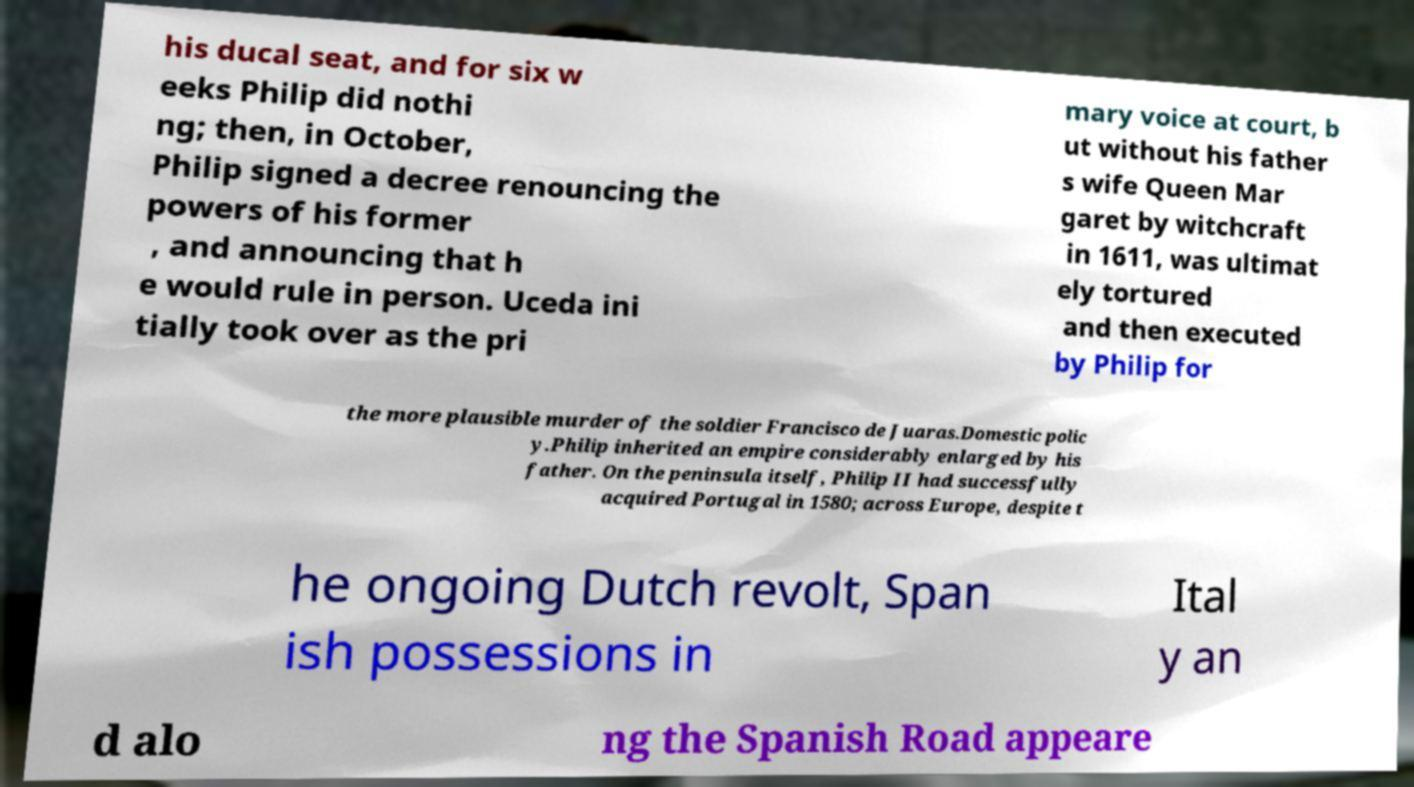I need the written content from this picture converted into text. Can you do that? his ducal seat, and for six w eeks Philip did nothi ng; then, in October, Philip signed a decree renouncing the powers of his former , and announcing that h e would rule in person. Uceda ini tially took over as the pri mary voice at court, b ut without his father s wife Queen Mar garet by witchcraft in 1611, was ultimat ely tortured and then executed by Philip for the more plausible murder of the soldier Francisco de Juaras.Domestic polic y.Philip inherited an empire considerably enlarged by his father. On the peninsula itself, Philip II had successfully acquired Portugal in 1580; across Europe, despite t he ongoing Dutch revolt, Span ish possessions in Ital y an d alo ng the Spanish Road appeare 